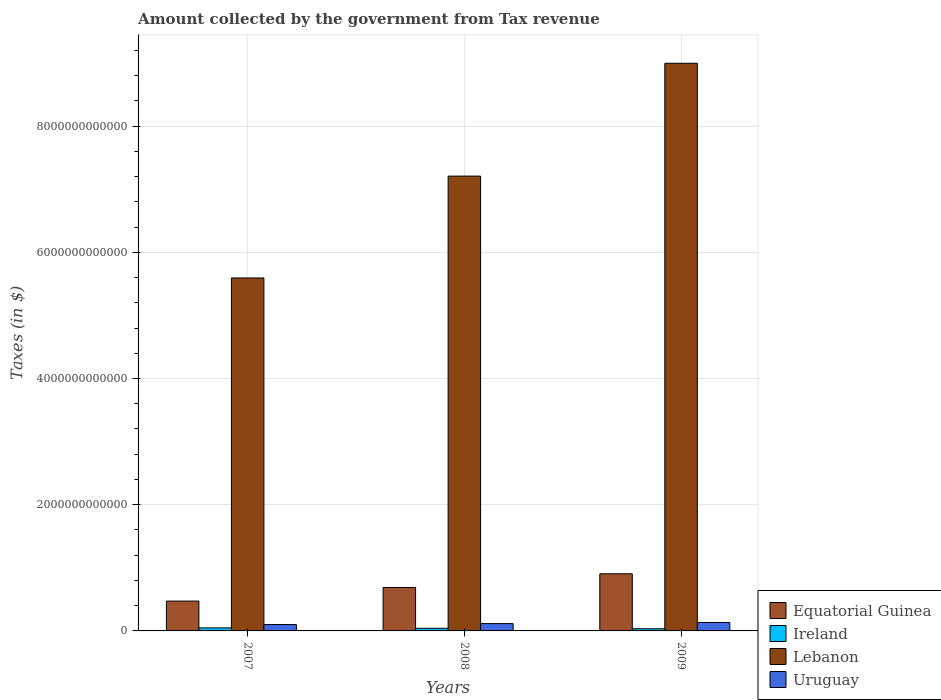Are the number of bars per tick equal to the number of legend labels?
Your answer should be compact. Yes. Are the number of bars on each tick of the X-axis equal?
Give a very brief answer. Yes. How many bars are there on the 2nd tick from the left?
Provide a short and direct response. 4. How many bars are there on the 1st tick from the right?
Provide a succinct answer. 4. What is the amount collected by the government from tax revenue in Uruguay in 2007?
Offer a terse response. 1.01e+11. Across all years, what is the maximum amount collected by the government from tax revenue in Lebanon?
Your answer should be very brief. 9.00e+12. Across all years, what is the minimum amount collected by the government from tax revenue in Ireland?
Provide a short and direct response. 3.45e+1. In which year was the amount collected by the government from tax revenue in Uruguay minimum?
Provide a succinct answer. 2007. What is the total amount collected by the government from tax revenue in Lebanon in the graph?
Provide a succinct answer. 2.18e+13. What is the difference between the amount collected by the government from tax revenue in Equatorial Guinea in 2007 and that in 2008?
Keep it short and to the point. -2.16e+11. What is the difference between the amount collected by the government from tax revenue in Ireland in 2007 and the amount collected by the government from tax revenue in Uruguay in 2009?
Provide a short and direct response. -8.55e+1. What is the average amount collected by the government from tax revenue in Ireland per year?
Ensure brevity in your answer.  4.16e+1. In the year 2009, what is the difference between the amount collected by the government from tax revenue in Uruguay and amount collected by the government from tax revenue in Lebanon?
Keep it short and to the point. -8.86e+12. What is the ratio of the amount collected by the government from tax revenue in Ireland in 2008 to that in 2009?
Ensure brevity in your answer.  1.22. Is the amount collected by the government from tax revenue in Lebanon in 2007 less than that in 2008?
Make the answer very short. Yes. Is the difference between the amount collected by the government from tax revenue in Uruguay in 2007 and 2008 greater than the difference between the amount collected by the government from tax revenue in Lebanon in 2007 and 2008?
Offer a very short reply. Yes. What is the difference between the highest and the second highest amount collected by the government from tax revenue in Lebanon?
Offer a very short reply. 1.79e+12. What is the difference between the highest and the lowest amount collected by the government from tax revenue in Lebanon?
Your response must be concise. 3.40e+12. In how many years, is the amount collected by the government from tax revenue in Lebanon greater than the average amount collected by the government from tax revenue in Lebanon taken over all years?
Make the answer very short. 1. Is it the case that in every year, the sum of the amount collected by the government from tax revenue in Equatorial Guinea and amount collected by the government from tax revenue in Ireland is greater than the sum of amount collected by the government from tax revenue in Lebanon and amount collected by the government from tax revenue in Uruguay?
Your answer should be compact. No. What does the 4th bar from the left in 2009 represents?
Your response must be concise. Uruguay. What does the 1st bar from the right in 2007 represents?
Your response must be concise. Uruguay. Are all the bars in the graph horizontal?
Ensure brevity in your answer.  No. How many years are there in the graph?
Offer a terse response. 3. What is the difference between two consecutive major ticks on the Y-axis?
Give a very brief answer. 2.00e+12. Are the values on the major ticks of Y-axis written in scientific E-notation?
Make the answer very short. No. Does the graph contain grids?
Make the answer very short. Yes. Where does the legend appear in the graph?
Your answer should be compact. Bottom right. How are the legend labels stacked?
Keep it short and to the point. Vertical. What is the title of the graph?
Ensure brevity in your answer.  Amount collected by the government from Tax revenue. Does "Sub-Saharan Africa (all income levels)" appear as one of the legend labels in the graph?
Your answer should be compact. No. What is the label or title of the Y-axis?
Give a very brief answer. Taxes (in $). What is the Taxes (in $) of Equatorial Guinea in 2007?
Keep it short and to the point. 4.73e+11. What is the Taxes (in $) of Ireland in 2007?
Your answer should be compact. 4.83e+1. What is the Taxes (in $) of Lebanon in 2007?
Keep it short and to the point. 5.59e+12. What is the Taxes (in $) of Uruguay in 2007?
Give a very brief answer. 1.01e+11. What is the Taxes (in $) of Equatorial Guinea in 2008?
Give a very brief answer. 6.89e+11. What is the Taxes (in $) of Ireland in 2008?
Ensure brevity in your answer.  4.19e+1. What is the Taxes (in $) of Lebanon in 2008?
Make the answer very short. 7.21e+12. What is the Taxes (in $) in Uruguay in 2008?
Provide a succinct answer. 1.16e+11. What is the Taxes (in $) in Equatorial Guinea in 2009?
Offer a terse response. 9.06e+11. What is the Taxes (in $) in Ireland in 2009?
Make the answer very short. 3.45e+1. What is the Taxes (in $) in Lebanon in 2009?
Give a very brief answer. 9.00e+12. What is the Taxes (in $) of Uruguay in 2009?
Your answer should be compact. 1.34e+11. Across all years, what is the maximum Taxes (in $) of Equatorial Guinea?
Provide a succinct answer. 9.06e+11. Across all years, what is the maximum Taxes (in $) of Ireland?
Provide a short and direct response. 4.83e+1. Across all years, what is the maximum Taxes (in $) in Lebanon?
Offer a very short reply. 9.00e+12. Across all years, what is the maximum Taxes (in $) of Uruguay?
Make the answer very short. 1.34e+11. Across all years, what is the minimum Taxes (in $) of Equatorial Guinea?
Ensure brevity in your answer.  4.73e+11. Across all years, what is the minimum Taxes (in $) in Ireland?
Give a very brief answer. 3.45e+1. Across all years, what is the minimum Taxes (in $) of Lebanon?
Ensure brevity in your answer.  5.59e+12. Across all years, what is the minimum Taxes (in $) of Uruguay?
Make the answer very short. 1.01e+11. What is the total Taxes (in $) in Equatorial Guinea in the graph?
Provide a succinct answer. 2.07e+12. What is the total Taxes (in $) of Ireland in the graph?
Provide a short and direct response. 1.25e+11. What is the total Taxes (in $) of Lebanon in the graph?
Your answer should be very brief. 2.18e+13. What is the total Taxes (in $) of Uruguay in the graph?
Provide a short and direct response. 3.51e+11. What is the difference between the Taxes (in $) of Equatorial Guinea in 2007 and that in 2008?
Provide a short and direct response. -2.16e+11. What is the difference between the Taxes (in $) of Ireland in 2007 and that in 2008?
Offer a very short reply. 6.43e+09. What is the difference between the Taxes (in $) of Lebanon in 2007 and that in 2008?
Provide a short and direct response. -1.61e+12. What is the difference between the Taxes (in $) in Uruguay in 2007 and that in 2008?
Your answer should be compact. -1.49e+1. What is the difference between the Taxes (in $) in Equatorial Guinea in 2007 and that in 2009?
Your answer should be compact. -4.33e+11. What is the difference between the Taxes (in $) of Ireland in 2007 and that in 2009?
Offer a very short reply. 1.39e+1. What is the difference between the Taxes (in $) of Lebanon in 2007 and that in 2009?
Give a very brief answer. -3.40e+12. What is the difference between the Taxes (in $) of Uruguay in 2007 and that in 2009?
Keep it short and to the point. -3.26e+1. What is the difference between the Taxes (in $) in Equatorial Guinea in 2008 and that in 2009?
Your response must be concise. -2.17e+11. What is the difference between the Taxes (in $) in Ireland in 2008 and that in 2009?
Your answer should be very brief. 7.44e+09. What is the difference between the Taxes (in $) in Lebanon in 2008 and that in 2009?
Your answer should be compact. -1.79e+12. What is the difference between the Taxes (in $) of Uruguay in 2008 and that in 2009?
Ensure brevity in your answer.  -1.77e+1. What is the difference between the Taxes (in $) in Equatorial Guinea in 2007 and the Taxes (in $) in Ireland in 2008?
Give a very brief answer. 4.31e+11. What is the difference between the Taxes (in $) of Equatorial Guinea in 2007 and the Taxes (in $) of Lebanon in 2008?
Offer a very short reply. -6.73e+12. What is the difference between the Taxes (in $) in Equatorial Guinea in 2007 and the Taxes (in $) in Uruguay in 2008?
Your answer should be very brief. 3.57e+11. What is the difference between the Taxes (in $) in Ireland in 2007 and the Taxes (in $) in Lebanon in 2008?
Your response must be concise. -7.16e+12. What is the difference between the Taxes (in $) of Ireland in 2007 and the Taxes (in $) of Uruguay in 2008?
Your answer should be very brief. -6.77e+1. What is the difference between the Taxes (in $) in Lebanon in 2007 and the Taxes (in $) in Uruguay in 2008?
Keep it short and to the point. 5.48e+12. What is the difference between the Taxes (in $) in Equatorial Guinea in 2007 and the Taxes (in $) in Ireland in 2009?
Keep it short and to the point. 4.38e+11. What is the difference between the Taxes (in $) in Equatorial Guinea in 2007 and the Taxes (in $) in Lebanon in 2009?
Provide a succinct answer. -8.52e+12. What is the difference between the Taxes (in $) of Equatorial Guinea in 2007 and the Taxes (in $) of Uruguay in 2009?
Your response must be concise. 3.39e+11. What is the difference between the Taxes (in $) of Ireland in 2007 and the Taxes (in $) of Lebanon in 2009?
Your answer should be very brief. -8.95e+12. What is the difference between the Taxes (in $) of Ireland in 2007 and the Taxes (in $) of Uruguay in 2009?
Your answer should be compact. -8.55e+1. What is the difference between the Taxes (in $) of Lebanon in 2007 and the Taxes (in $) of Uruguay in 2009?
Your answer should be very brief. 5.46e+12. What is the difference between the Taxes (in $) in Equatorial Guinea in 2008 and the Taxes (in $) in Ireland in 2009?
Your answer should be compact. 6.54e+11. What is the difference between the Taxes (in $) of Equatorial Guinea in 2008 and the Taxes (in $) of Lebanon in 2009?
Offer a terse response. -8.31e+12. What is the difference between the Taxes (in $) in Equatorial Guinea in 2008 and the Taxes (in $) in Uruguay in 2009?
Your response must be concise. 5.55e+11. What is the difference between the Taxes (in $) of Ireland in 2008 and the Taxes (in $) of Lebanon in 2009?
Keep it short and to the point. -8.95e+12. What is the difference between the Taxes (in $) of Ireland in 2008 and the Taxes (in $) of Uruguay in 2009?
Your answer should be compact. -9.19e+1. What is the difference between the Taxes (in $) of Lebanon in 2008 and the Taxes (in $) of Uruguay in 2009?
Give a very brief answer. 7.07e+12. What is the average Taxes (in $) in Equatorial Guinea per year?
Your response must be concise. 6.89e+11. What is the average Taxes (in $) in Ireland per year?
Ensure brevity in your answer.  4.16e+1. What is the average Taxes (in $) in Lebanon per year?
Offer a terse response. 7.27e+12. What is the average Taxes (in $) of Uruguay per year?
Make the answer very short. 1.17e+11. In the year 2007, what is the difference between the Taxes (in $) in Equatorial Guinea and Taxes (in $) in Ireland?
Make the answer very short. 4.24e+11. In the year 2007, what is the difference between the Taxes (in $) of Equatorial Guinea and Taxes (in $) of Lebanon?
Your response must be concise. -5.12e+12. In the year 2007, what is the difference between the Taxes (in $) of Equatorial Guinea and Taxes (in $) of Uruguay?
Provide a succinct answer. 3.72e+11. In the year 2007, what is the difference between the Taxes (in $) in Ireland and Taxes (in $) in Lebanon?
Provide a succinct answer. -5.54e+12. In the year 2007, what is the difference between the Taxes (in $) of Ireland and Taxes (in $) of Uruguay?
Give a very brief answer. -5.28e+1. In the year 2007, what is the difference between the Taxes (in $) of Lebanon and Taxes (in $) of Uruguay?
Offer a terse response. 5.49e+12. In the year 2008, what is the difference between the Taxes (in $) of Equatorial Guinea and Taxes (in $) of Ireland?
Provide a succinct answer. 6.47e+11. In the year 2008, what is the difference between the Taxes (in $) of Equatorial Guinea and Taxes (in $) of Lebanon?
Provide a succinct answer. -6.52e+12. In the year 2008, what is the difference between the Taxes (in $) of Equatorial Guinea and Taxes (in $) of Uruguay?
Offer a terse response. 5.73e+11. In the year 2008, what is the difference between the Taxes (in $) in Ireland and Taxes (in $) in Lebanon?
Provide a succinct answer. -7.17e+12. In the year 2008, what is the difference between the Taxes (in $) of Ireland and Taxes (in $) of Uruguay?
Your answer should be compact. -7.42e+1. In the year 2008, what is the difference between the Taxes (in $) in Lebanon and Taxes (in $) in Uruguay?
Offer a very short reply. 7.09e+12. In the year 2009, what is the difference between the Taxes (in $) in Equatorial Guinea and Taxes (in $) in Ireland?
Provide a succinct answer. 8.71e+11. In the year 2009, what is the difference between the Taxes (in $) of Equatorial Guinea and Taxes (in $) of Lebanon?
Offer a terse response. -8.09e+12. In the year 2009, what is the difference between the Taxes (in $) in Equatorial Guinea and Taxes (in $) in Uruguay?
Offer a terse response. 7.72e+11. In the year 2009, what is the difference between the Taxes (in $) in Ireland and Taxes (in $) in Lebanon?
Keep it short and to the point. -8.96e+12. In the year 2009, what is the difference between the Taxes (in $) of Ireland and Taxes (in $) of Uruguay?
Provide a short and direct response. -9.93e+1. In the year 2009, what is the difference between the Taxes (in $) in Lebanon and Taxes (in $) in Uruguay?
Your answer should be very brief. 8.86e+12. What is the ratio of the Taxes (in $) in Equatorial Guinea in 2007 to that in 2008?
Give a very brief answer. 0.69. What is the ratio of the Taxes (in $) in Ireland in 2007 to that in 2008?
Provide a short and direct response. 1.15. What is the ratio of the Taxes (in $) in Lebanon in 2007 to that in 2008?
Your answer should be compact. 0.78. What is the ratio of the Taxes (in $) in Uruguay in 2007 to that in 2008?
Your answer should be very brief. 0.87. What is the ratio of the Taxes (in $) in Equatorial Guinea in 2007 to that in 2009?
Provide a succinct answer. 0.52. What is the ratio of the Taxes (in $) of Ireland in 2007 to that in 2009?
Make the answer very short. 1.4. What is the ratio of the Taxes (in $) in Lebanon in 2007 to that in 2009?
Keep it short and to the point. 0.62. What is the ratio of the Taxes (in $) of Uruguay in 2007 to that in 2009?
Give a very brief answer. 0.76. What is the ratio of the Taxes (in $) in Equatorial Guinea in 2008 to that in 2009?
Offer a very short reply. 0.76. What is the ratio of the Taxes (in $) in Ireland in 2008 to that in 2009?
Provide a succinct answer. 1.22. What is the ratio of the Taxes (in $) in Lebanon in 2008 to that in 2009?
Your answer should be very brief. 0.8. What is the ratio of the Taxes (in $) in Uruguay in 2008 to that in 2009?
Your answer should be compact. 0.87. What is the difference between the highest and the second highest Taxes (in $) in Equatorial Guinea?
Provide a short and direct response. 2.17e+11. What is the difference between the highest and the second highest Taxes (in $) of Ireland?
Your answer should be compact. 6.43e+09. What is the difference between the highest and the second highest Taxes (in $) in Lebanon?
Your answer should be compact. 1.79e+12. What is the difference between the highest and the second highest Taxes (in $) in Uruguay?
Make the answer very short. 1.77e+1. What is the difference between the highest and the lowest Taxes (in $) in Equatorial Guinea?
Make the answer very short. 4.33e+11. What is the difference between the highest and the lowest Taxes (in $) in Ireland?
Give a very brief answer. 1.39e+1. What is the difference between the highest and the lowest Taxes (in $) in Lebanon?
Your response must be concise. 3.40e+12. What is the difference between the highest and the lowest Taxes (in $) of Uruguay?
Provide a short and direct response. 3.26e+1. 